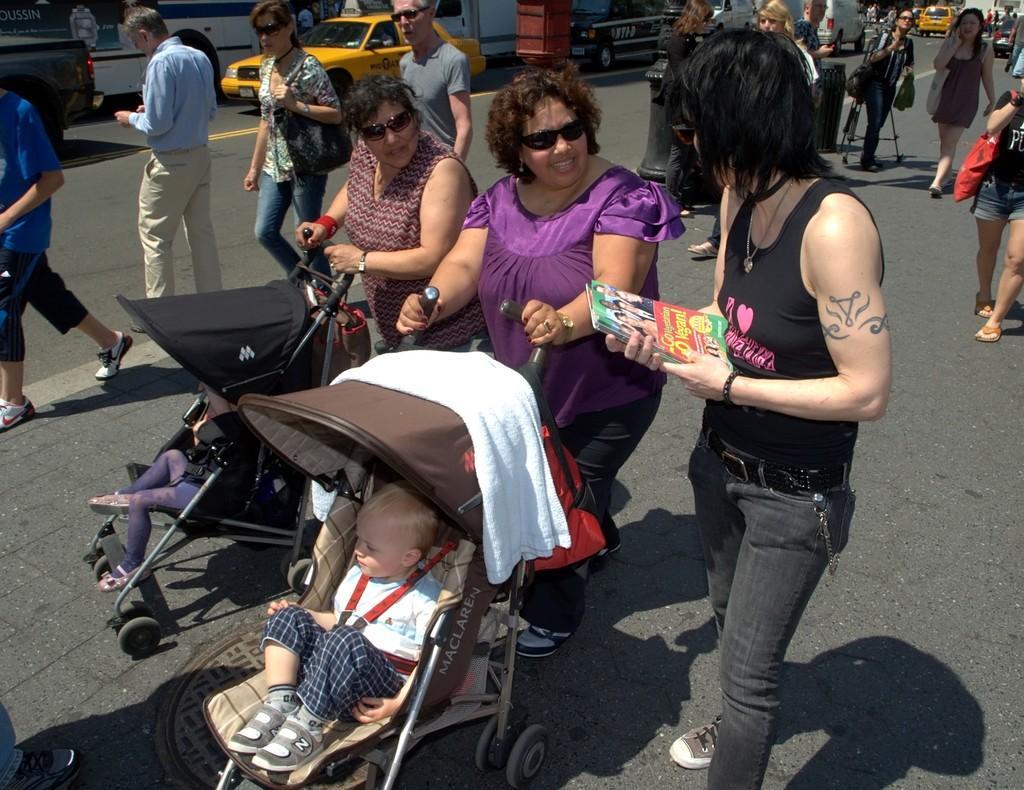Describe this image in one or two sentences. In this image we can see a few people, we can see the children in a baby stroller, we can see the vehicles on the road. 